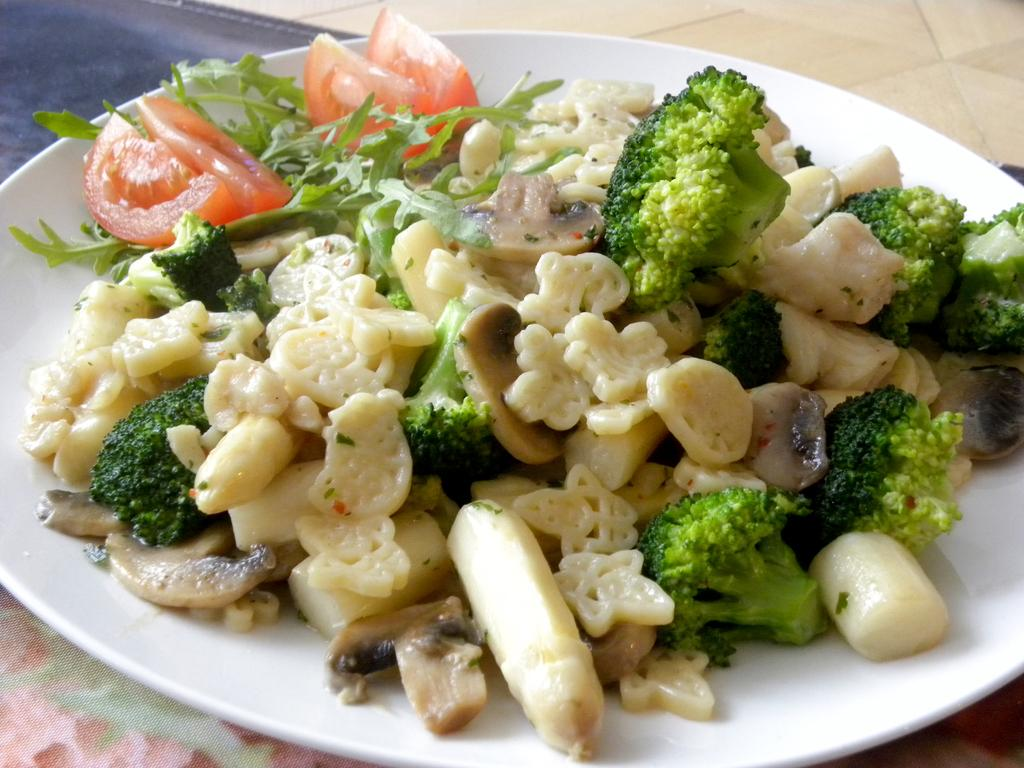What is on the plate that is visible in the image? There is a plate containing food in the image. Where is the plate located in the image? The plate is placed on a table. What can be seen in the background of the image? There is a floor visible in the background of the image. What channel is the food on the plate tuned to in the image? The food on the plate is not a television channel, so it cannot be tuned to any channel. 